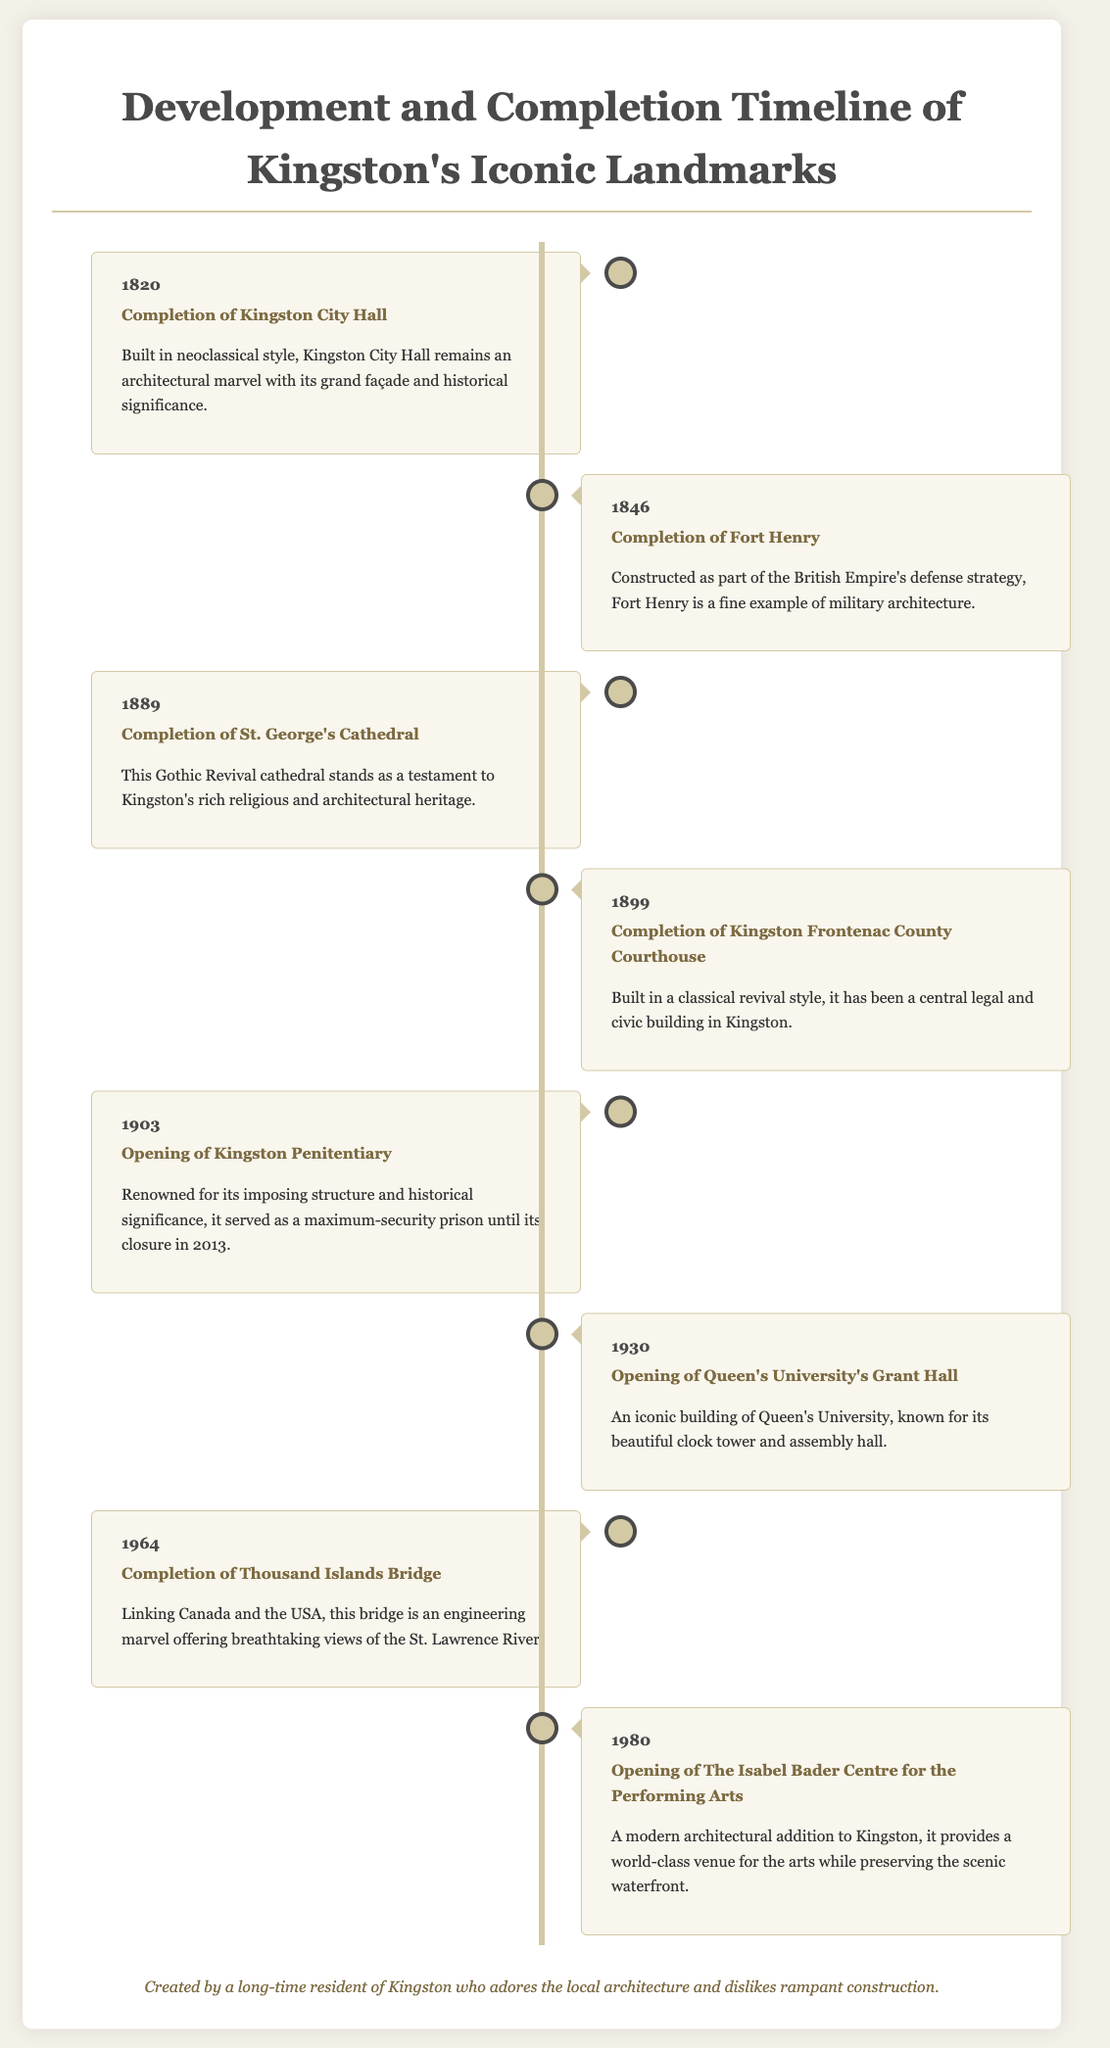what year was Kingston City Hall completed? Kingston City Hall's completion year is stated in the document.
Answer: 1820 who completed Fort Henry? The document indicates Fort Henry was completed in 1846, but it does not specify who completed it.
Answer: Fort Henry what architectural style is St. George's Cathedral? The document describes St. George's Cathedral as Gothic Revival.
Answer: Gothic Revival what year did Kingston Penitentiary open? The opening year of the Kingston Penitentiary is explicitly mentioned.
Answer: 1903 which landmark opened in 1980? The document provides details about landmarks including The Isabel Bader Centre for the Performing Arts which opened in 1980.
Answer: The Isabel Bader Centre for the Performing Arts what is the significance of the Thousand Islands Bridge? The document describes the Thousand Islands Bridge as an engineering marvel linking Canada and the USA.
Answer: Engineering marvel how many years are between the completion of Kingston City Hall and Fort Henry? The years between the two events are calculated by the difference in their completion years.
Answer: 26 years which landmark has a clock tower? The document specifies that Queen's University's Grant Hall is known for its clock tower.
Answer: Grant Hall 